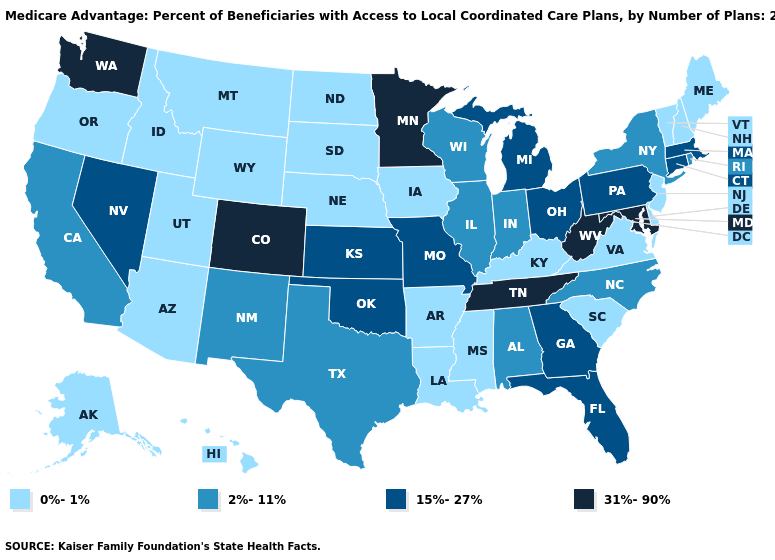Is the legend a continuous bar?
Quick response, please. No. Does South Carolina have a lower value than Arkansas?
Write a very short answer. No. Does Arizona have a lower value than New Hampshire?
Quick response, please. No. What is the highest value in states that border South Carolina?
Keep it brief. 15%-27%. Name the states that have a value in the range 2%-11%?
Short answer required. Alabama, California, Illinois, Indiana, North Carolina, New Mexico, New York, Rhode Island, Texas, Wisconsin. What is the lowest value in the West?
Answer briefly. 0%-1%. What is the lowest value in the South?
Keep it brief. 0%-1%. How many symbols are there in the legend?
Write a very short answer. 4. Does New Mexico have a lower value than Massachusetts?
Short answer required. Yes. Which states have the highest value in the USA?
Give a very brief answer. Colorado, Maryland, Minnesota, Tennessee, Washington, West Virginia. Name the states that have a value in the range 31%-90%?
Concise answer only. Colorado, Maryland, Minnesota, Tennessee, Washington, West Virginia. How many symbols are there in the legend?
Give a very brief answer. 4. Which states have the lowest value in the West?
Give a very brief answer. Alaska, Arizona, Hawaii, Idaho, Montana, Oregon, Utah, Wyoming. What is the value of Minnesota?
Give a very brief answer. 31%-90%. 